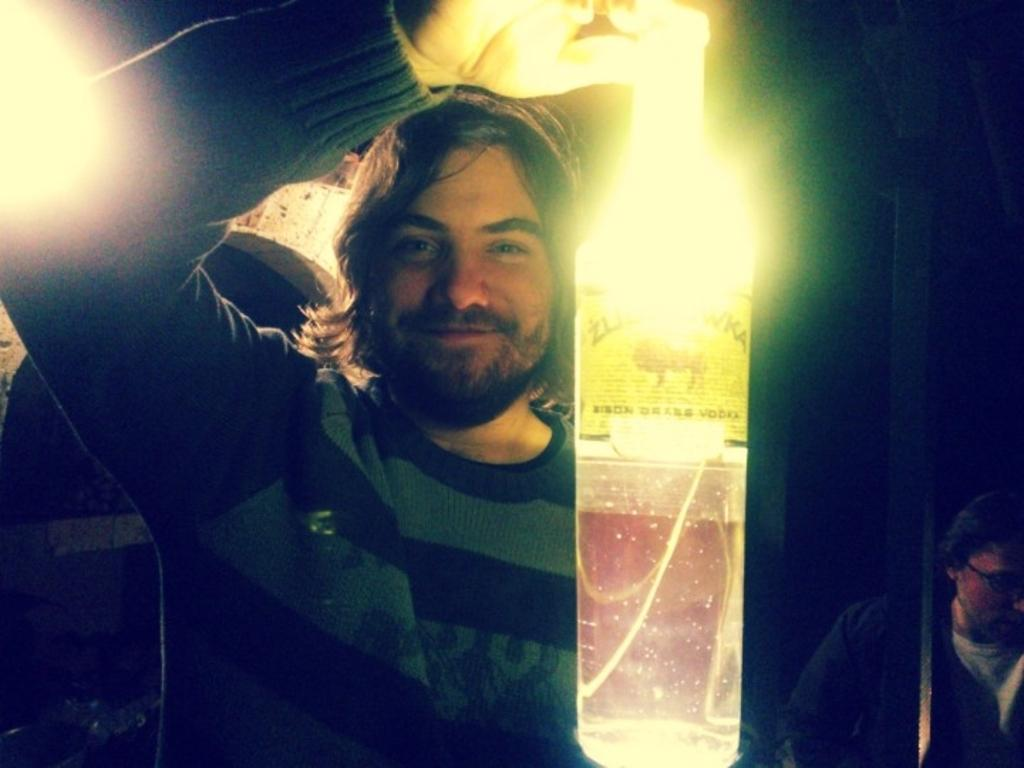How many people are in the image? There are two people in the image. What can be observed about the clothing of the people in the image? The people are wearing different color dresses. What object is one person holding in the image? One person is holding a bottle. What type of illumination is present in the image? There are lights visible in the image. What is the color of the background in the image? The background of the image is black. What type of house is visible in the image? There is no house present in the image. What type of voyage are the people embarking on in the image? There is no indication of a voyage in the image; it simply shows two people wearing different color dresses and one holding a bottle. How many babies are visible in the image? There are no babies present in the image. 